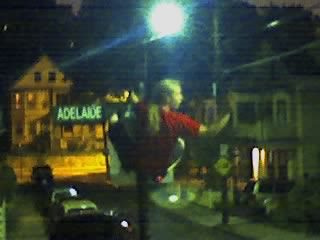How many women are dressed in red on the right side of the street sign? Based on the image, it appears that there is one individual dressed in red located on the right side of the street sign. 